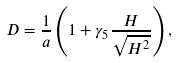Convert formula to latex. <formula><loc_0><loc_0><loc_500><loc_500>D = \frac { 1 } { a } \left ( 1 + \gamma _ { 5 } \frac { H } { \sqrt { H ^ { 2 } } } \right ) ,</formula> 